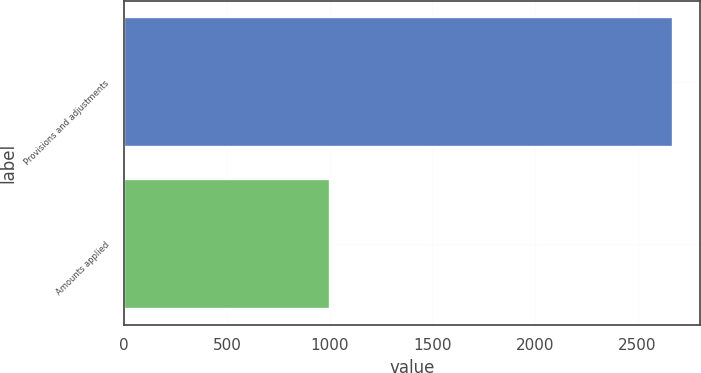Convert chart. <chart><loc_0><loc_0><loc_500><loc_500><bar_chart><fcel>Provisions and adjustments<fcel>Amounts applied<nl><fcel>2672<fcel>1002<nl></chart> 